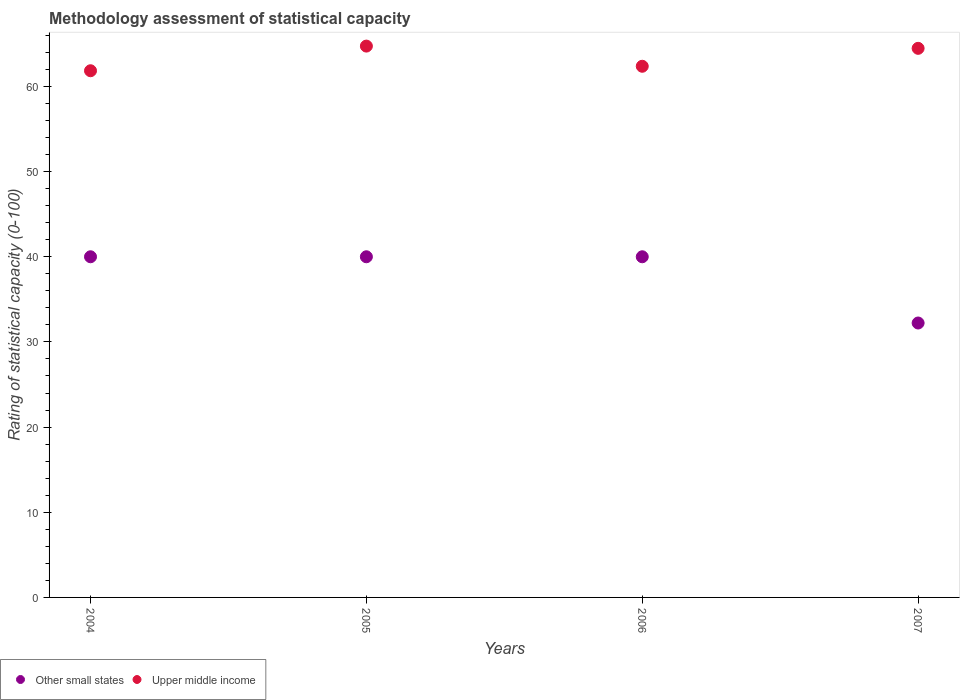How many different coloured dotlines are there?
Provide a short and direct response. 2. Is the number of dotlines equal to the number of legend labels?
Make the answer very short. Yes. What is the rating of statistical capacity in Other small states in 2004?
Your answer should be compact. 40. Across all years, what is the maximum rating of statistical capacity in Upper middle income?
Offer a very short reply. 64.74. Across all years, what is the minimum rating of statistical capacity in Upper middle income?
Your answer should be very brief. 61.84. In which year was the rating of statistical capacity in Upper middle income maximum?
Make the answer very short. 2005. What is the total rating of statistical capacity in Upper middle income in the graph?
Give a very brief answer. 253.42. What is the difference between the rating of statistical capacity in Other small states in 2004 and that in 2005?
Your response must be concise. 0. What is the difference between the rating of statistical capacity in Upper middle income in 2004 and the rating of statistical capacity in Other small states in 2005?
Provide a short and direct response. 21.84. What is the average rating of statistical capacity in Upper middle income per year?
Provide a succinct answer. 63.36. In the year 2007, what is the difference between the rating of statistical capacity in Upper middle income and rating of statistical capacity in Other small states?
Provide a short and direct response. 32.25. In how many years, is the rating of statistical capacity in Upper middle income greater than 42?
Your answer should be compact. 4. What is the ratio of the rating of statistical capacity in Upper middle income in 2004 to that in 2006?
Provide a short and direct response. 0.99. What is the difference between the highest and the second highest rating of statistical capacity in Upper middle income?
Your answer should be very brief. 0.26. What is the difference between the highest and the lowest rating of statistical capacity in Upper middle income?
Offer a terse response. 2.89. Is the sum of the rating of statistical capacity in Upper middle income in 2004 and 2007 greater than the maximum rating of statistical capacity in Other small states across all years?
Make the answer very short. Yes. Does the rating of statistical capacity in Other small states monotonically increase over the years?
Ensure brevity in your answer.  No. How many years are there in the graph?
Provide a succinct answer. 4. Does the graph contain grids?
Provide a succinct answer. No. How many legend labels are there?
Your answer should be compact. 2. How are the legend labels stacked?
Make the answer very short. Horizontal. What is the title of the graph?
Keep it short and to the point. Methodology assessment of statistical capacity. Does "Hong Kong" appear as one of the legend labels in the graph?
Give a very brief answer. No. What is the label or title of the X-axis?
Offer a very short reply. Years. What is the label or title of the Y-axis?
Keep it short and to the point. Rating of statistical capacity (0-100). What is the Rating of statistical capacity (0-100) in Other small states in 2004?
Provide a short and direct response. 40. What is the Rating of statistical capacity (0-100) of Upper middle income in 2004?
Offer a very short reply. 61.84. What is the Rating of statistical capacity (0-100) in Other small states in 2005?
Give a very brief answer. 40. What is the Rating of statistical capacity (0-100) of Upper middle income in 2005?
Offer a very short reply. 64.74. What is the Rating of statistical capacity (0-100) in Other small states in 2006?
Your response must be concise. 40. What is the Rating of statistical capacity (0-100) of Upper middle income in 2006?
Your response must be concise. 62.37. What is the Rating of statistical capacity (0-100) of Other small states in 2007?
Your answer should be very brief. 32.22. What is the Rating of statistical capacity (0-100) of Upper middle income in 2007?
Provide a succinct answer. 64.47. Across all years, what is the maximum Rating of statistical capacity (0-100) of Upper middle income?
Give a very brief answer. 64.74. Across all years, what is the minimum Rating of statistical capacity (0-100) in Other small states?
Ensure brevity in your answer.  32.22. Across all years, what is the minimum Rating of statistical capacity (0-100) of Upper middle income?
Provide a short and direct response. 61.84. What is the total Rating of statistical capacity (0-100) in Other small states in the graph?
Give a very brief answer. 152.22. What is the total Rating of statistical capacity (0-100) in Upper middle income in the graph?
Keep it short and to the point. 253.42. What is the difference between the Rating of statistical capacity (0-100) in Other small states in 2004 and that in 2005?
Ensure brevity in your answer.  0. What is the difference between the Rating of statistical capacity (0-100) in Upper middle income in 2004 and that in 2005?
Ensure brevity in your answer.  -2.89. What is the difference between the Rating of statistical capacity (0-100) of Upper middle income in 2004 and that in 2006?
Offer a terse response. -0.53. What is the difference between the Rating of statistical capacity (0-100) in Other small states in 2004 and that in 2007?
Offer a very short reply. 7.78. What is the difference between the Rating of statistical capacity (0-100) in Upper middle income in 2004 and that in 2007?
Your answer should be compact. -2.63. What is the difference between the Rating of statistical capacity (0-100) in Upper middle income in 2005 and that in 2006?
Ensure brevity in your answer.  2.37. What is the difference between the Rating of statistical capacity (0-100) of Other small states in 2005 and that in 2007?
Your response must be concise. 7.78. What is the difference between the Rating of statistical capacity (0-100) of Upper middle income in 2005 and that in 2007?
Offer a very short reply. 0.26. What is the difference between the Rating of statistical capacity (0-100) in Other small states in 2006 and that in 2007?
Offer a terse response. 7.78. What is the difference between the Rating of statistical capacity (0-100) in Upper middle income in 2006 and that in 2007?
Provide a succinct answer. -2.11. What is the difference between the Rating of statistical capacity (0-100) in Other small states in 2004 and the Rating of statistical capacity (0-100) in Upper middle income in 2005?
Make the answer very short. -24.74. What is the difference between the Rating of statistical capacity (0-100) in Other small states in 2004 and the Rating of statistical capacity (0-100) in Upper middle income in 2006?
Offer a very short reply. -22.37. What is the difference between the Rating of statistical capacity (0-100) of Other small states in 2004 and the Rating of statistical capacity (0-100) of Upper middle income in 2007?
Make the answer very short. -24.47. What is the difference between the Rating of statistical capacity (0-100) of Other small states in 2005 and the Rating of statistical capacity (0-100) of Upper middle income in 2006?
Ensure brevity in your answer.  -22.37. What is the difference between the Rating of statistical capacity (0-100) of Other small states in 2005 and the Rating of statistical capacity (0-100) of Upper middle income in 2007?
Offer a terse response. -24.47. What is the difference between the Rating of statistical capacity (0-100) of Other small states in 2006 and the Rating of statistical capacity (0-100) of Upper middle income in 2007?
Your answer should be very brief. -24.47. What is the average Rating of statistical capacity (0-100) of Other small states per year?
Your response must be concise. 38.06. What is the average Rating of statistical capacity (0-100) of Upper middle income per year?
Your answer should be compact. 63.36. In the year 2004, what is the difference between the Rating of statistical capacity (0-100) of Other small states and Rating of statistical capacity (0-100) of Upper middle income?
Provide a short and direct response. -21.84. In the year 2005, what is the difference between the Rating of statistical capacity (0-100) in Other small states and Rating of statistical capacity (0-100) in Upper middle income?
Ensure brevity in your answer.  -24.74. In the year 2006, what is the difference between the Rating of statistical capacity (0-100) of Other small states and Rating of statistical capacity (0-100) of Upper middle income?
Your response must be concise. -22.37. In the year 2007, what is the difference between the Rating of statistical capacity (0-100) of Other small states and Rating of statistical capacity (0-100) of Upper middle income?
Provide a short and direct response. -32.25. What is the ratio of the Rating of statistical capacity (0-100) in Other small states in 2004 to that in 2005?
Offer a terse response. 1. What is the ratio of the Rating of statistical capacity (0-100) in Upper middle income in 2004 to that in 2005?
Provide a short and direct response. 0.96. What is the ratio of the Rating of statistical capacity (0-100) in Other small states in 2004 to that in 2006?
Keep it short and to the point. 1. What is the ratio of the Rating of statistical capacity (0-100) in Upper middle income in 2004 to that in 2006?
Give a very brief answer. 0.99. What is the ratio of the Rating of statistical capacity (0-100) in Other small states in 2004 to that in 2007?
Keep it short and to the point. 1.24. What is the ratio of the Rating of statistical capacity (0-100) in Upper middle income in 2004 to that in 2007?
Your response must be concise. 0.96. What is the ratio of the Rating of statistical capacity (0-100) in Upper middle income in 2005 to that in 2006?
Ensure brevity in your answer.  1.04. What is the ratio of the Rating of statistical capacity (0-100) of Other small states in 2005 to that in 2007?
Offer a terse response. 1.24. What is the ratio of the Rating of statistical capacity (0-100) of Other small states in 2006 to that in 2007?
Offer a terse response. 1.24. What is the ratio of the Rating of statistical capacity (0-100) in Upper middle income in 2006 to that in 2007?
Your response must be concise. 0.97. What is the difference between the highest and the second highest Rating of statistical capacity (0-100) of Other small states?
Provide a short and direct response. 0. What is the difference between the highest and the second highest Rating of statistical capacity (0-100) of Upper middle income?
Keep it short and to the point. 0.26. What is the difference between the highest and the lowest Rating of statistical capacity (0-100) of Other small states?
Your answer should be very brief. 7.78. What is the difference between the highest and the lowest Rating of statistical capacity (0-100) in Upper middle income?
Make the answer very short. 2.89. 